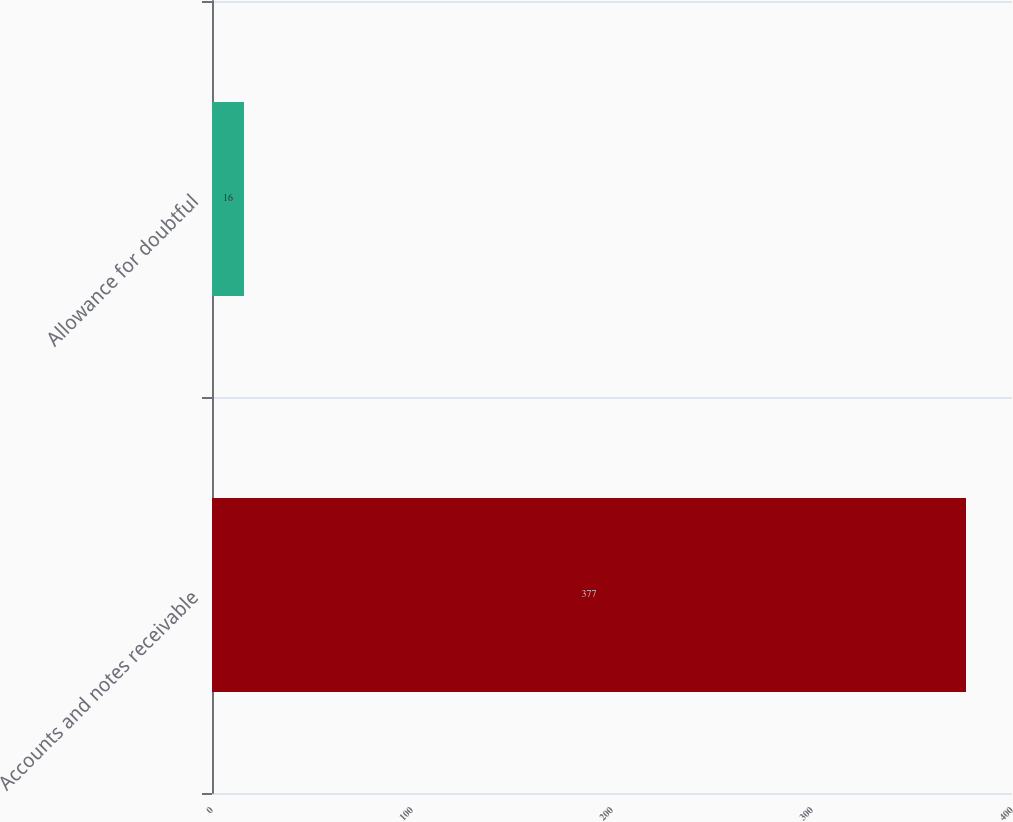<chart> <loc_0><loc_0><loc_500><loc_500><bar_chart><fcel>Accounts and notes receivable<fcel>Allowance for doubtful<nl><fcel>377<fcel>16<nl></chart> 